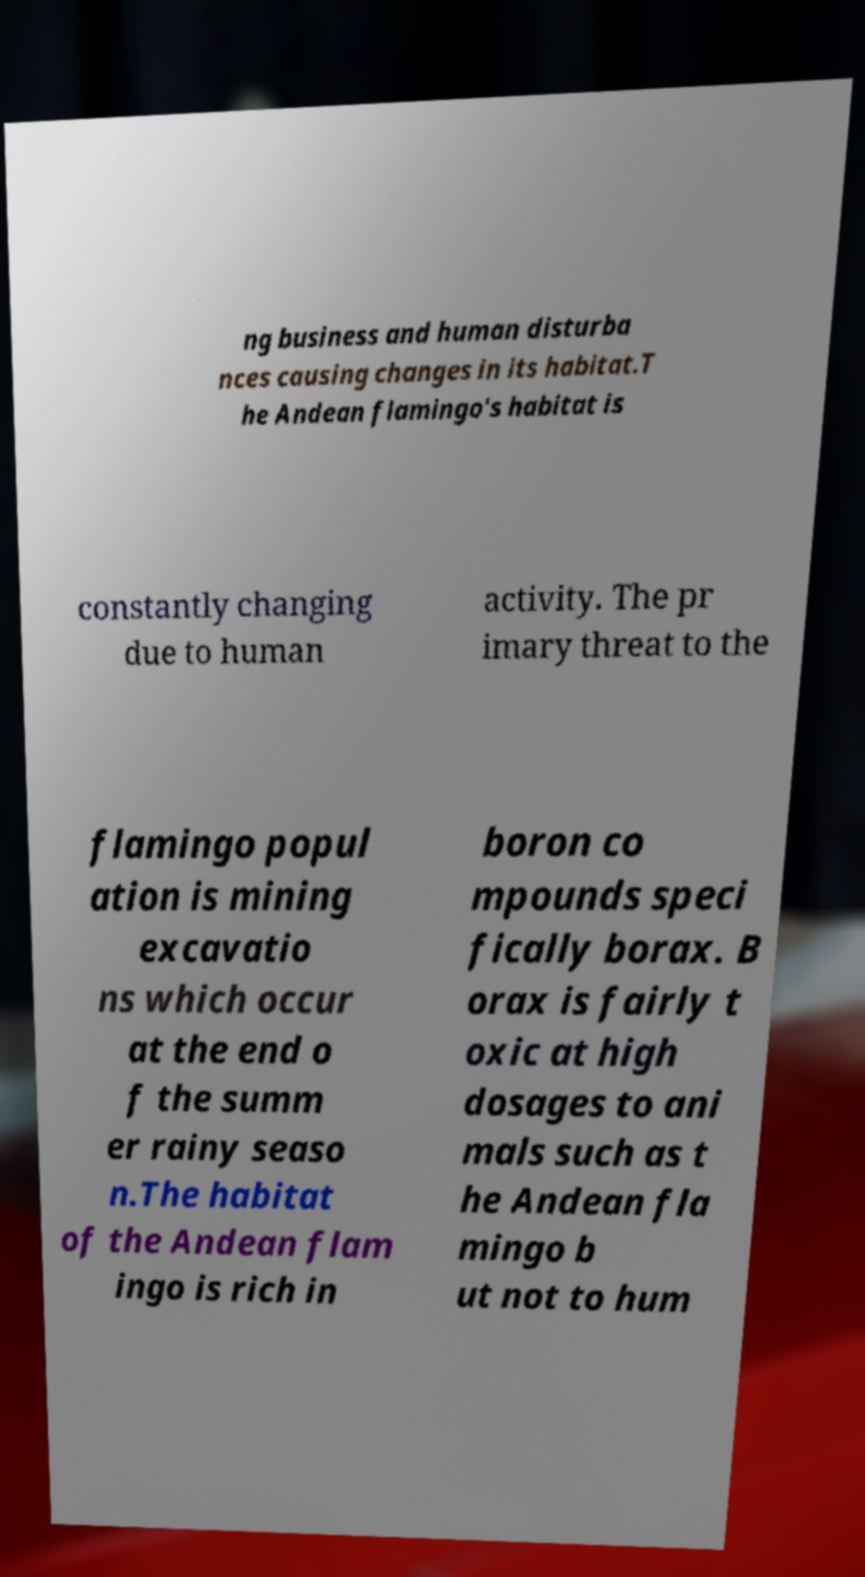I need the written content from this picture converted into text. Can you do that? ng business and human disturba nces causing changes in its habitat.T he Andean flamingo's habitat is constantly changing due to human activity. The pr imary threat to the flamingo popul ation is mining excavatio ns which occur at the end o f the summ er rainy seaso n.The habitat of the Andean flam ingo is rich in boron co mpounds speci fically borax. B orax is fairly t oxic at high dosages to ani mals such as t he Andean fla mingo b ut not to hum 